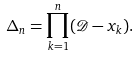Convert formula to latex. <formula><loc_0><loc_0><loc_500><loc_500>\Delta _ { n } = \prod _ { k = 1 } ^ { n } ( \mathcal { D } - x _ { k } ) .</formula> 